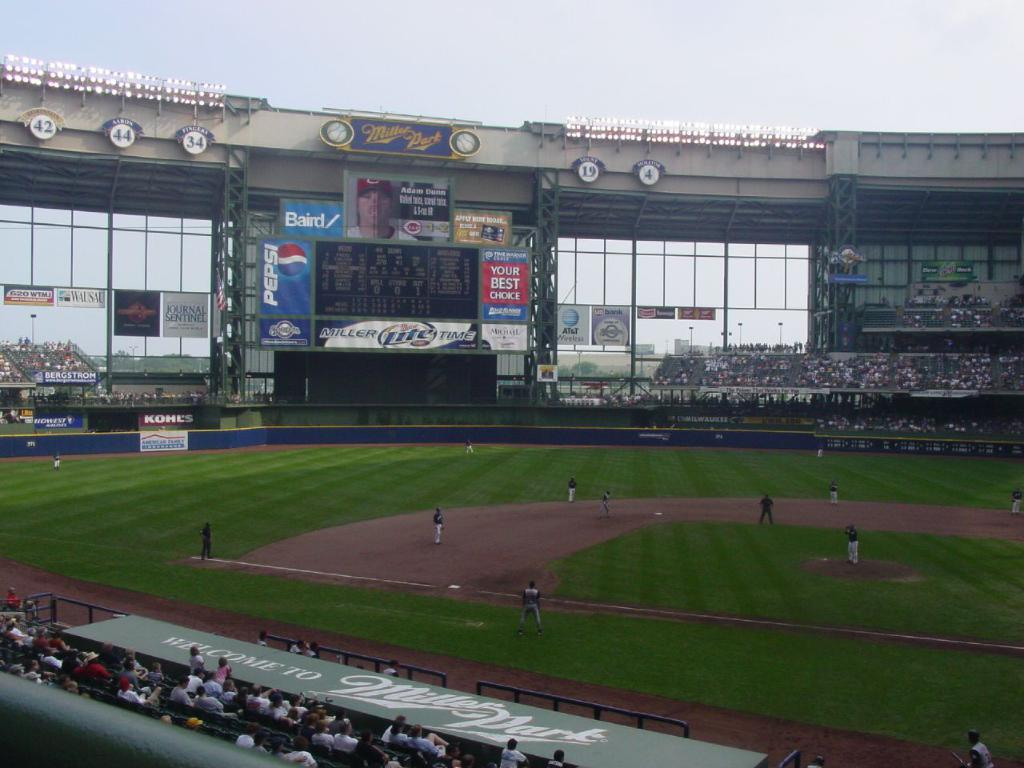<image>
Provide a brief description of the given image. Baseball field that has an ad that says "Your Best Choice". 